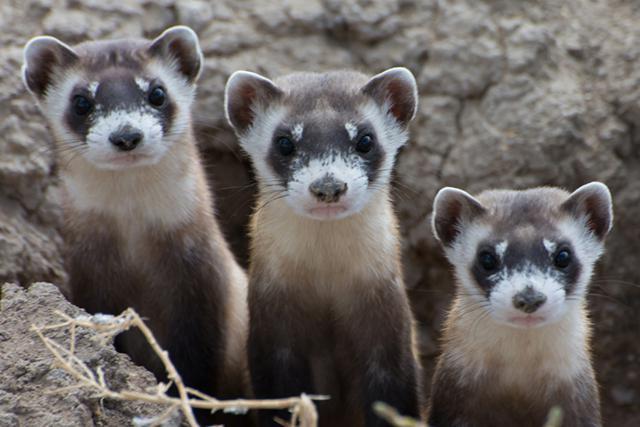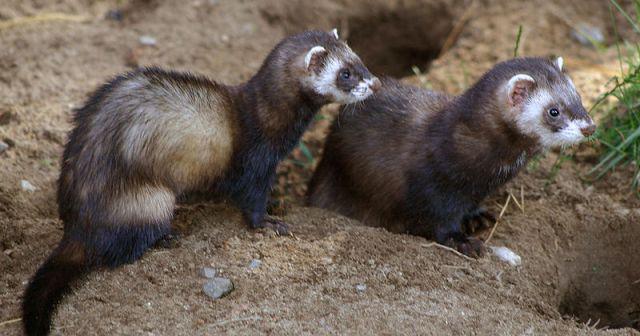The first image is the image on the left, the second image is the image on the right. For the images shown, is this caption "An image shows one ferret standing with its tail outstretched behind it, while a second image shows three or more ferrets." true? Answer yes or no. No. The first image is the image on the left, the second image is the image on the right. Assess this claim about the two images: "The combined images contain five ferrets, and at least three are peering up from a low spot.". Correct or not? Answer yes or no. Yes. 